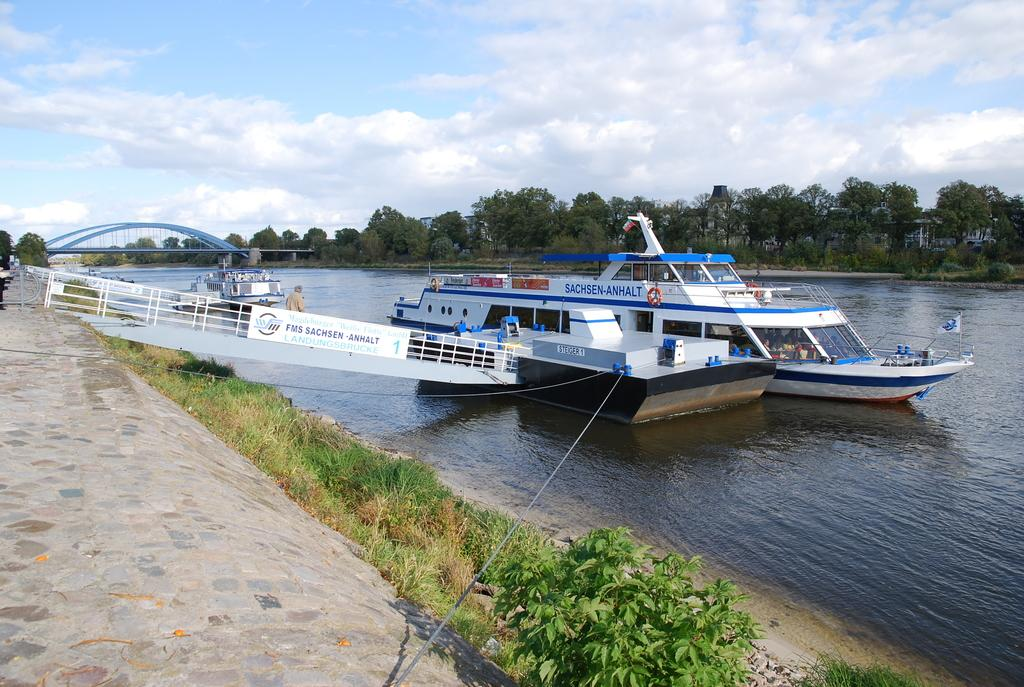What type of structure is present in the image? There is a bridge in the image. Can you describe the bridge's design? The bridge has arches and railings. What else can be seen in the image related to water? There are boats in the image. What type of surface is visible in the image? There is grass in the image. What other types of vegetation are present in the image? There are plants and trees in the image. How would you describe the sky in the image? The sky is cloudy in the image. Are there any people in the image? Yes, there are people in the image. What other objects can be seen in the image? There is a flag and other objects in the image. What year is the meeting taking place in the image? There is no meeting depicted in the image, so it is not possible to determine the year. 